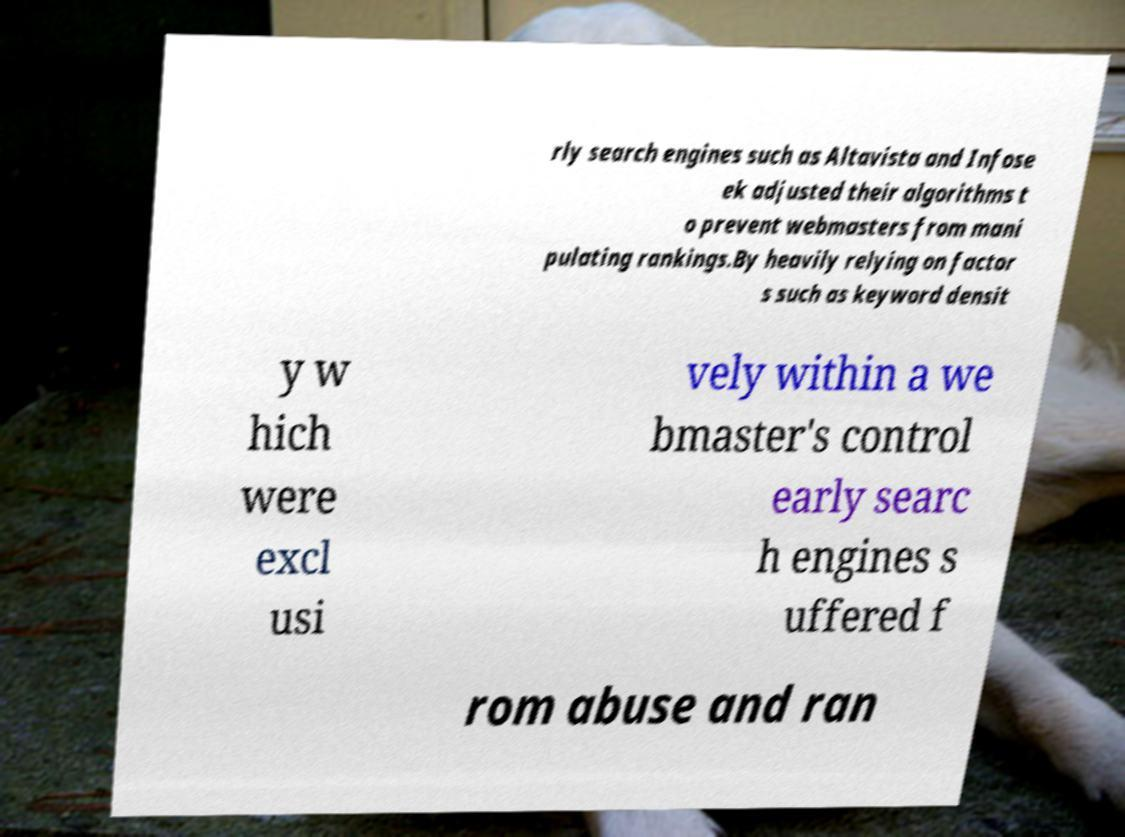For documentation purposes, I need the text within this image transcribed. Could you provide that? rly search engines such as Altavista and Infose ek adjusted their algorithms t o prevent webmasters from mani pulating rankings.By heavily relying on factor s such as keyword densit y w hich were excl usi vely within a we bmaster's control early searc h engines s uffered f rom abuse and ran 